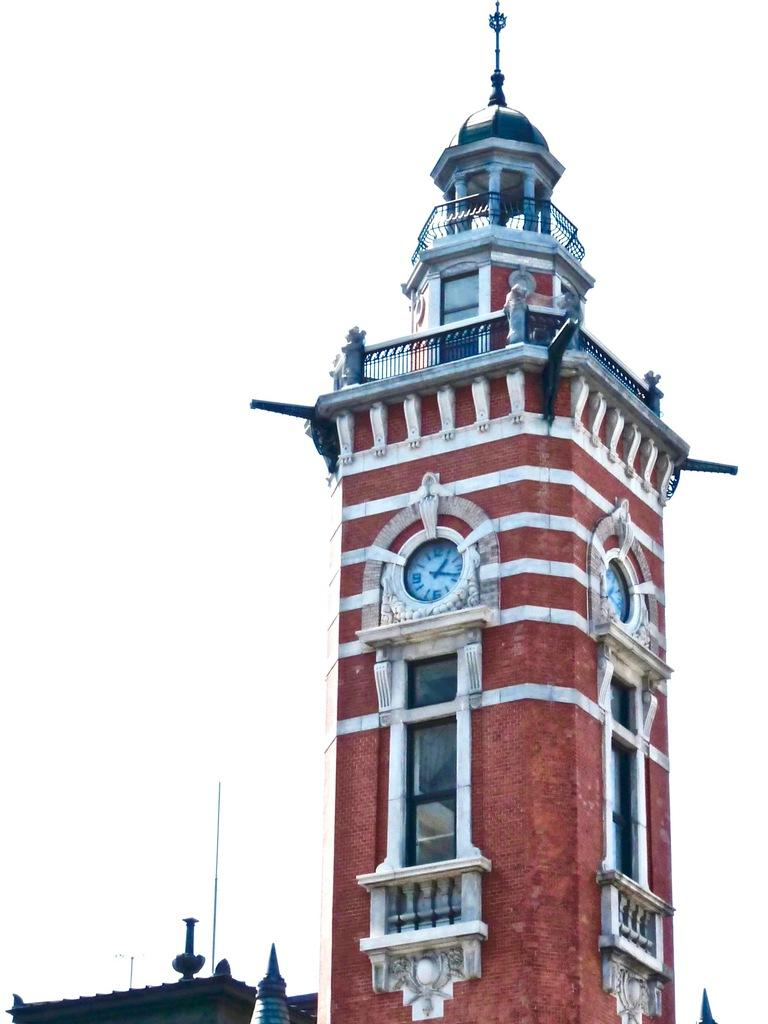What is the main structure in the image? There is a building in the image. What is attached to the walls of the building? Blocks are attached to the walls of the building. What colors are used for the building in the image? The building is in red and white color. What is the tendency of the lumber in the image? There is no lumber present in the image, so it is not possible to determine its tendency. 